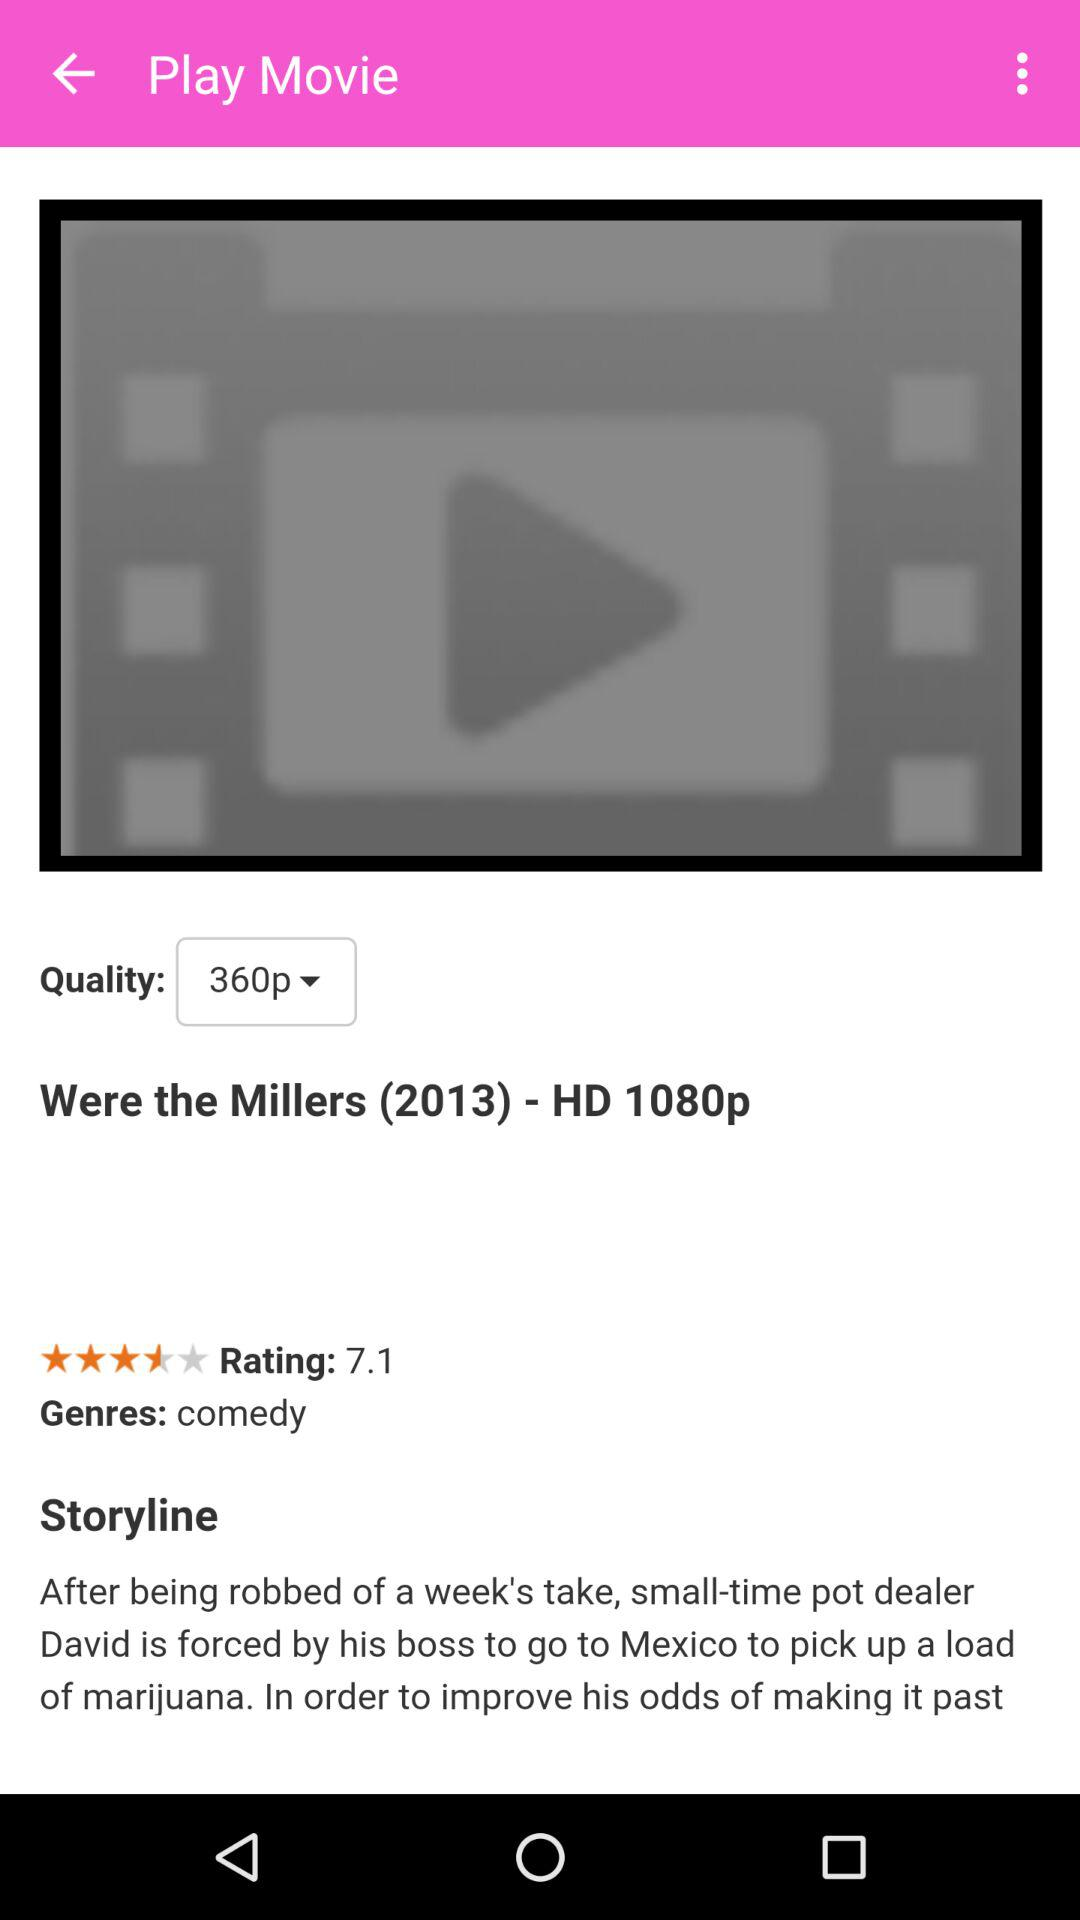What is the duration of the movie?
When the provided information is insufficient, respond with <no answer>. <no answer> 